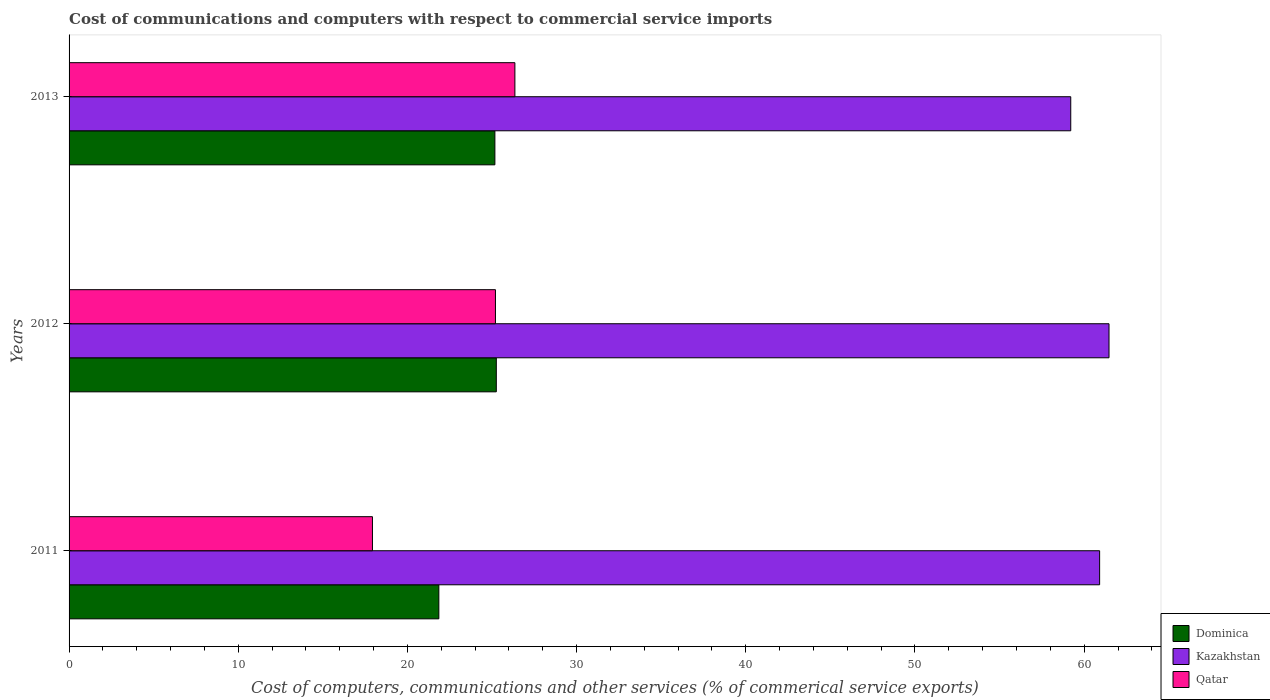How many groups of bars are there?
Provide a succinct answer. 3. Are the number of bars per tick equal to the number of legend labels?
Provide a short and direct response. Yes. Are the number of bars on each tick of the Y-axis equal?
Provide a short and direct response. Yes. How many bars are there on the 1st tick from the bottom?
Give a very brief answer. 3. What is the label of the 2nd group of bars from the top?
Your answer should be very brief. 2012. In how many cases, is the number of bars for a given year not equal to the number of legend labels?
Provide a succinct answer. 0. What is the cost of communications and computers in Qatar in 2013?
Offer a very short reply. 26.35. Across all years, what is the maximum cost of communications and computers in Dominica?
Provide a short and direct response. 25.25. Across all years, what is the minimum cost of communications and computers in Kazakhstan?
Give a very brief answer. 59.21. In which year was the cost of communications and computers in Dominica maximum?
Your answer should be very brief. 2012. What is the total cost of communications and computers in Kazakhstan in the graph?
Provide a succinct answer. 181.59. What is the difference between the cost of communications and computers in Qatar in 2011 and that in 2013?
Provide a succinct answer. -8.42. What is the difference between the cost of communications and computers in Qatar in 2011 and the cost of communications and computers in Kazakhstan in 2012?
Your response must be concise. -43.54. What is the average cost of communications and computers in Qatar per year?
Make the answer very short. 23.16. In the year 2012, what is the difference between the cost of communications and computers in Qatar and cost of communications and computers in Dominica?
Your answer should be very brief. -0.05. What is the ratio of the cost of communications and computers in Qatar in 2011 to that in 2013?
Make the answer very short. 0.68. What is the difference between the highest and the second highest cost of communications and computers in Kazakhstan?
Your response must be concise. 0.56. What is the difference between the highest and the lowest cost of communications and computers in Qatar?
Give a very brief answer. 8.42. In how many years, is the cost of communications and computers in Kazakhstan greater than the average cost of communications and computers in Kazakhstan taken over all years?
Provide a succinct answer. 2. Is the sum of the cost of communications and computers in Qatar in 2011 and 2013 greater than the maximum cost of communications and computers in Kazakhstan across all years?
Offer a terse response. No. What does the 3rd bar from the top in 2011 represents?
Offer a very short reply. Dominica. What does the 3rd bar from the bottom in 2011 represents?
Ensure brevity in your answer.  Qatar. Is it the case that in every year, the sum of the cost of communications and computers in Kazakhstan and cost of communications and computers in Dominica is greater than the cost of communications and computers in Qatar?
Make the answer very short. Yes. How many bars are there?
Provide a succinct answer. 9. Are all the bars in the graph horizontal?
Your response must be concise. Yes. What is the difference between two consecutive major ticks on the X-axis?
Your answer should be compact. 10. Does the graph contain any zero values?
Ensure brevity in your answer.  No. What is the title of the graph?
Make the answer very short. Cost of communications and computers with respect to commercial service imports. Does "Monaco" appear as one of the legend labels in the graph?
Keep it short and to the point. No. What is the label or title of the X-axis?
Offer a terse response. Cost of computers, communications and other services (% of commerical service exports). What is the label or title of the Y-axis?
Provide a succinct answer. Years. What is the Cost of computers, communications and other services (% of commerical service exports) in Dominica in 2011?
Offer a very short reply. 21.86. What is the Cost of computers, communications and other services (% of commerical service exports) in Kazakhstan in 2011?
Offer a terse response. 60.91. What is the Cost of computers, communications and other services (% of commerical service exports) of Qatar in 2011?
Your response must be concise. 17.93. What is the Cost of computers, communications and other services (% of commerical service exports) in Dominica in 2012?
Offer a very short reply. 25.25. What is the Cost of computers, communications and other services (% of commerical service exports) of Kazakhstan in 2012?
Your response must be concise. 61.47. What is the Cost of computers, communications and other services (% of commerical service exports) of Qatar in 2012?
Offer a terse response. 25.2. What is the Cost of computers, communications and other services (% of commerical service exports) in Dominica in 2013?
Ensure brevity in your answer.  25.17. What is the Cost of computers, communications and other services (% of commerical service exports) of Kazakhstan in 2013?
Provide a succinct answer. 59.21. What is the Cost of computers, communications and other services (% of commerical service exports) of Qatar in 2013?
Provide a short and direct response. 26.35. Across all years, what is the maximum Cost of computers, communications and other services (% of commerical service exports) in Dominica?
Your answer should be very brief. 25.25. Across all years, what is the maximum Cost of computers, communications and other services (% of commerical service exports) of Kazakhstan?
Your answer should be compact. 61.47. Across all years, what is the maximum Cost of computers, communications and other services (% of commerical service exports) in Qatar?
Provide a short and direct response. 26.35. Across all years, what is the minimum Cost of computers, communications and other services (% of commerical service exports) of Dominica?
Your answer should be compact. 21.86. Across all years, what is the minimum Cost of computers, communications and other services (% of commerical service exports) in Kazakhstan?
Keep it short and to the point. 59.21. Across all years, what is the minimum Cost of computers, communications and other services (% of commerical service exports) of Qatar?
Offer a very short reply. 17.93. What is the total Cost of computers, communications and other services (% of commerical service exports) of Dominica in the graph?
Keep it short and to the point. 72.28. What is the total Cost of computers, communications and other services (% of commerical service exports) of Kazakhstan in the graph?
Ensure brevity in your answer.  181.59. What is the total Cost of computers, communications and other services (% of commerical service exports) of Qatar in the graph?
Give a very brief answer. 69.49. What is the difference between the Cost of computers, communications and other services (% of commerical service exports) in Dominica in 2011 and that in 2012?
Provide a short and direct response. -3.4. What is the difference between the Cost of computers, communications and other services (% of commerical service exports) in Kazakhstan in 2011 and that in 2012?
Your answer should be very brief. -0.56. What is the difference between the Cost of computers, communications and other services (% of commerical service exports) in Qatar in 2011 and that in 2012?
Give a very brief answer. -7.27. What is the difference between the Cost of computers, communications and other services (% of commerical service exports) of Dominica in 2011 and that in 2013?
Keep it short and to the point. -3.31. What is the difference between the Cost of computers, communications and other services (% of commerical service exports) of Kazakhstan in 2011 and that in 2013?
Offer a terse response. 1.71. What is the difference between the Cost of computers, communications and other services (% of commerical service exports) of Qatar in 2011 and that in 2013?
Provide a short and direct response. -8.42. What is the difference between the Cost of computers, communications and other services (% of commerical service exports) in Dominica in 2012 and that in 2013?
Provide a succinct answer. 0.08. What is the difference between the Cost of computers, communications and other services (% of commerical service exports) in Kazakhstan in 2012 and that in 2013?
Offer a terse response. 2.26. What is the difference between the Cost of computers, communications and other services (% of commerical service exports) in Qatar in 2012 and that in 2013?
Provide a succinct answer. -1.15. What is the difference between the Cost of computers, communications and other services (% of commerical service exports) in Dominica in 2011 and the Cost of computers, communications and other services (% of commerical service exports) in Kazakhstan in 2012?
Keep it short and to the point. -39.61. What is the difference between the Cost of computers, communications and other services (% of commerical service exports) of Dominica in 2011 and the Cost of computers, communications and other services (% of commerical service exports) of Qatar in 2012?
Keep it short and to the point. -3.35. What is the difference between the Cost of computers, communications and other services (% of commerical service exports) of Kazakhstan in 2011 and the Cost of computers, communications and other services (% of commerical service exports) of Qatar in 2012?
Keep it short and to the point. 35.71. What is the difference between the Cost of computers, communications and other services (% of commerical service exports) of Dominica in 2011 and the Cost of computers, communications and other services (% of commerical service exports) of Kazakhstan in 2013?
Make the answer very short. -37.35. What is the difference between the Cost of computers, communications and other services (% of commerical service exports) in Dominica in 2011 and the Cost of computers, communications and other services (% of commerical service exports) in Qatar in 2013?
Keep it short and to the point. -4.49. What is the difference between the Cost of computers, communications and other services (% of commerical service exports) of Kazakhstan in 2011 and the Cost of computers, communications and other services (% of commerical service exports) of Qatar in 2013?
Your response must be concise. 34.56. What is the difference between the Cost of computers, communications and other services (% of commerical service exports) of Dominica in 2012 and the Cost of computers, communications and other services (% of commerical service exports) of Kazakhstan in 2013?
Your answer should be very brief. -33.95. What is the difference between the Cost of computers, communications and other services (% of commerical service exports) of Dominica in 2012 and the Cost of computers, communications and other services (% of commerical service exports) of Qatar in 2013?
Provide a succinct answer. -1.1. What is the difference between the Cost of computers, communications and other services (% of commerical service exports) of Kazakhstan in 2012 and the Cost of computers, communications and other services (% of commerical service exports) of Qatar in 2013?
Your response must be concise. 35.12. What is the average Cost of computers, communications and other services (% of commerical service exports) in Dominica per year?
Offer a terse response. 24.09. What is the average Cost of computers, communications and other services (% of commerical service exports) of Kazakhstan per year?
Ensure brevity in your answer.  60.53. What is the average Cost of computers, communications and other services (% of commerical service exports) of Qatar per year?
Make the answer very short. 23.16. In the year 2011, what is the difference between the Cost of computers, communications and other services (% of commerical service exports) of Dominica and Cost of computers, communications and other services (% of commerical service exports) of Kazakhstan?
Offer a very short reply. -39.06. In the year 2011, what is the difference between the Cost of computers, communications and other services (% of commerical service exports) in Dominica and Cost of computers, communications and other services (% of commerical service exports) in Qatar?
Your response must be concise. 3.92. In the year 2011, what is the difference between the Cost of computers, communications and other services (% of commerical service exports) in Kazakhstan and Cost of computers, communications and other services (% of commerical service exports) in Qatar?
Your answer should be very brief. 42.98. In the year 2012, what is the difference between the Cost of computers, communications and other services (% of commerical service exports) in Dominica and Cost of computers, communications and other services (% of commerical service exports) in Kazakhstan?
Your answer should be very brief. -36.21. In the year 2012, what is the difference between the Cost of computers, communications and other services (% of commerical service exports) in Dominica and Cost of computers, communications and other services (% of commerical service exports) in Qatar?
Offer a very short reply. 0.05. In the year 2012, what is the difference between the Cost of computers, communications and other services (% of commerical service exports) in Kazakhstan and Cost of computers, communications and other services (% of commerical service exports) in Qatar?
Your response must be concise. 36.27. In the year 2013, what is the difference between the Cost of computers, communications and other services (% of commerical service exports) in Dominica and Cost of computers, communications and other services (% of commerical service exports) in Kazakhstan?
Provide a succinct answer. -34.04. In the year 2013, what is the difference between the Cost of computers, communications and other services (% of commerical service exports) of Dominica and Cost of computers, communications and other services (% of commerical service exports) of Qatar?
Provide a succinct answer. -1.18. In the year 2013, what is the difference between the Cost of computers, communications and other services (% of commerical service exports) in Kazakhstan and Cost of computers, communications and other services (% of commerical service exports) in Qatar?
Provide a short and direct response. 32.86. What is the ratio of the Cost of computers, communications and other services (% of commerical service exports) of Dominica in 2011 to that in 2012?
Make the answer very short. 0.87. What is the ratio of the Cost of computers, communications and other services (% of commerical service exports) in Qatar in 2011 to that in 2012?
Offer a very short reply. 0.71. What is the ratio of the Cost of computers, communications and other services (% of commerical service exports) in Dominica in 2011 to that in 2013?
Ensure brevity in your answer.  0.87. What is the ratio of the Cost of computers, communications and other services (% of commerical service exports) in Kazakhstan in 2011 to that in 2013?
Offer a terse response. 1.03. What is the ratio of the Cost of computers, communications and other services (% of commerical service exports) of Qatar in 2011 to that in 2013?
Offer a terse response. 0.68. What is the ratio of the Cost of computers, communications and other services (% of commerical service exports) of Kazakhstan in 2012 to that in 2013?
Make the answer very short. 1.04. What is the ratio of the Cost of computers, communications and other services (% of commerical service exports) of Qatar in 2012 to that in 2013?
Keep it short and to the point. 0.96. What is the difference between the highest and the second highest Cost of computers, communications and other services (% of commerical service exports) in Dominica?
Provide a short and direct response. 0.08. What is the difference between the highest and the second highest Cost of computers, communications and other services (% of commerical service exports) of Kazakhstan?
Provide a succinct answer. 0.56. What is the difference between the highest and the second highest Cost of computers, communications and other services (% of commerical service exports) of Qatar?
Offer a very short reply. 1.15. What is the difference between the highest and the lowest Cost of computers, communications and other services (% of commerical service exports) in Dominica?
Make the answer very short. 3.4. What is the difference between the highest and the lowest Cost of computers, communications and other services (% of commerical service exports) of Kazakhstan?
Your answer should be compact. 2.26. What is the difference between the highest and the lowest Cost of computers, communications and other services (% of commerical service exports) of Qatar?
Offer a terse response. 8.42. 